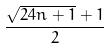<formula> <loc_0><loc_0><loc_500><loc_500>\frac { \sqrt { 2 4 n + 1 } + 1 } { 2 }</formula> 